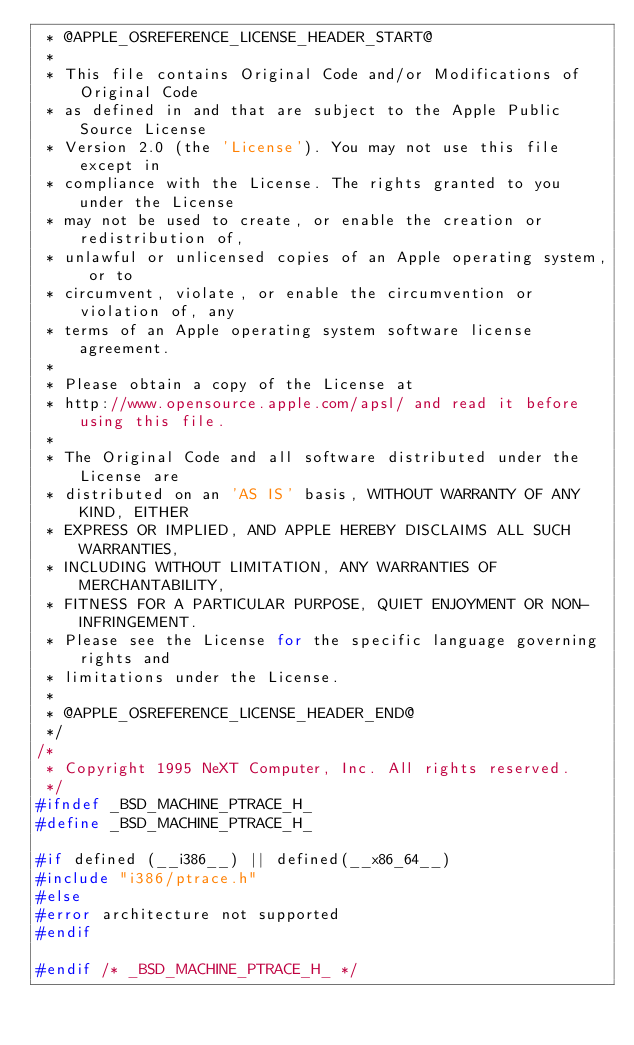<code> <loc_0><loc_0><loc_500><loc_500><_C_> * @APPLE_OSREFERENCE_LICENSE_HEADER_START@
 * 
 * This file contains Original Code and/or Modifications of Original Code
 * as defined in and that are subject to the Apple Public Source License
 * Version 2.0 (the 'License'). You may not use this file except in
 * compliance with the License. The rights granted to you under the License
 * may not be used to create, or enable the creation or redistribution of,
 * unlawful or unlicensed copies of an Apple operating system, or to
 * circumvent, violate, or enable the circumvention or violation of, any
 * terms of an Apple operating system software license agreement.
 * 
 * Please obtain a copy of the License at
 * http://www.opensource.apple.com/apsl/ and read it before using this file.
 * 
 * The Original Code and all software distributed under the License are
 * distributed on an 'AS IS' basis, WITHOUT WARRANTY OF ANY KIND, EITHER
 * EXPRESS OR IMPLIED, AND APPLE HEREBY DISCLAIMS ALL SUCH WARRANTIES,
 * INCLUDING WITHOUT LIMITATION, ANY WARRANTIES OF MERCHANTABILITY,
 * FITNESS FOR A PARTICULAR PURPOSE, QUIET ENJOYMENT OR NON-INFRINGEMENT.
 * Please see the License for the specific language governing rights and
 * limitations under the License.
 * 
 * @APPLE_OSREFERENCE_LICENSE_HEADER_END@
 */
/*
 * Copyright 1995 NeXT Computer, Inc. All rights reserved.
 */
#ifndef _BSD_MACHINE_PTRACE_H_
#define _BSD_MACHINE_PTRACE_H_

#if defined (__i386__) || defined(__x86_64__)
#include "i386/ptrace.h"
#else
#error architecture not supported
#endif

#endif /* _BSD_MACHINE_PTRACE_H_ */
</code> 